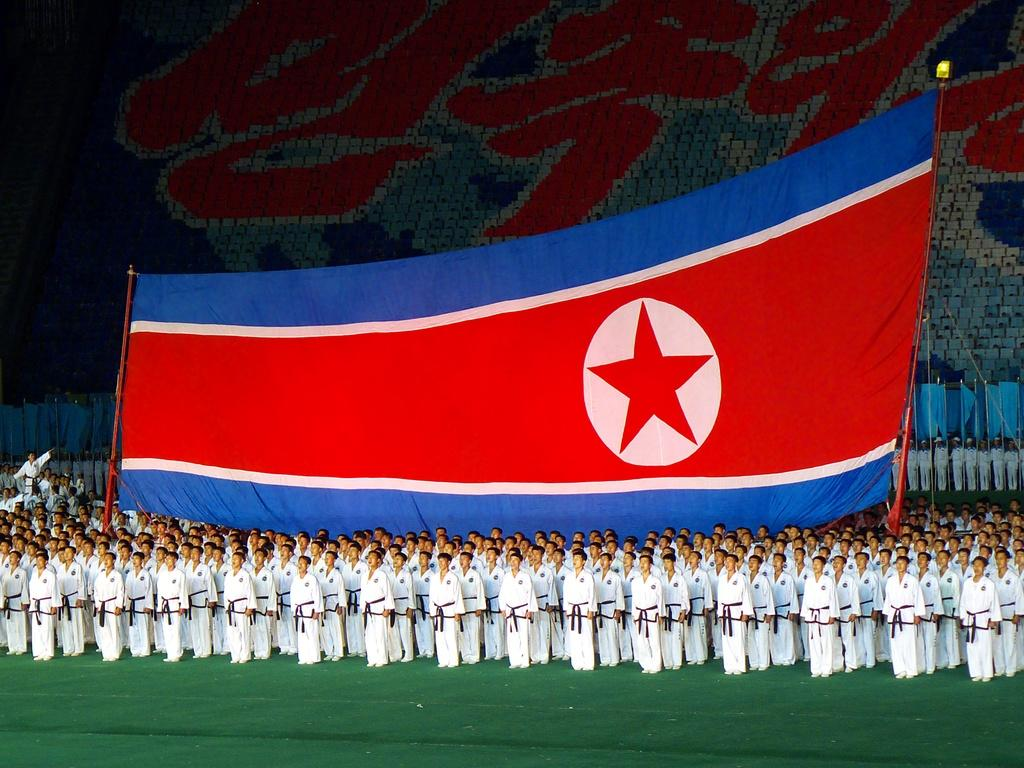Who is present in the image? There are people in the image. What are the people wearing? The people are wearing karate uniforms. What else can be seen in the image besides the people? There is a huge flag in the image. What colors are featured on the flag? The flag is blue and red in color. What type of cows can be seen grazing in the background of the image? There are no cows present in the image; it features people wearing karate uniforms and a blue and red flag. 